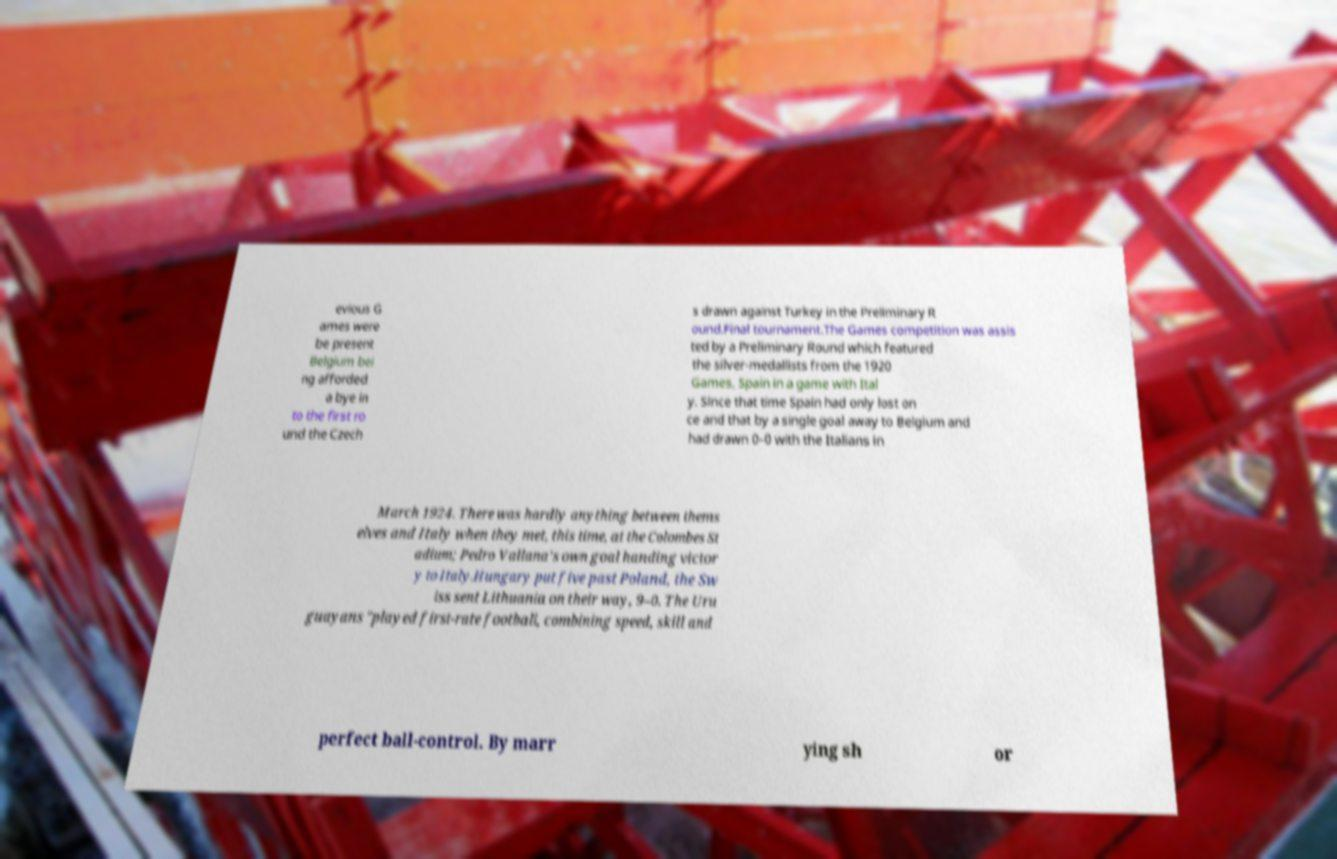Can you read and provide the text displayed in the image?This photo seems to have some interesting text. Can you extract and type it out for me? evious G ames were be present Belgium bei ng afforded a bye in to the first ro und the Czech s drawn against Turkey in the Preliminary R ound.Final tournament.The Games competition was assis ted by a Preliminary Round which featured the silver-medallists from the 1920 Games, Spain in a game with Ital y. Since that time Spain had only lost on ce and that by a single goal away to Belgium and had drawn 0–0 with the Italians in March 1924. There was hardly anything between thems elves and Italy when they met, this time, at the Colombes St adium; Pedro Vallana's own goal handing victor y to Italy.Hungary put five past Poland, the Sw iss sent Lithuania on their way, 9–0. The Uru guayans "played first-rate football, combining speed, skill and perfect ball-control. By marr ying sh or 